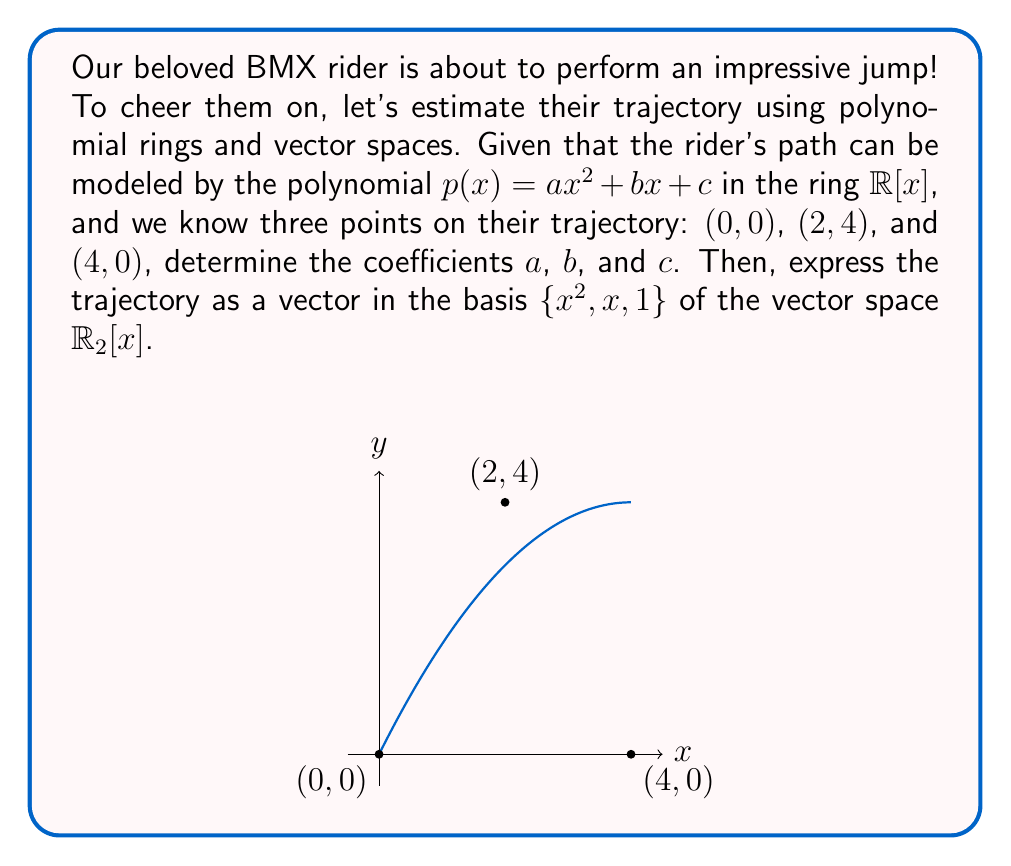Could you help me with this problem? Let's approach this step-by-step:

1) We have the polynomial $p(x) = ax^2 + bx + c$ in the ring $\mathbb{R}[x]$.

2) We know three points: $(0, 0)$, $(2, 4)$, and $(4, 0)$. Let's use these to create a system of equations:

   $p(0) = 0$: $a(0)^2 + b(0) + c = 0$, so $c = 0$
   $p(2) = 4$: $a(2)^2 + b(2) + c = 4$
   $p(4) = 0$: $a(4)^2 + b(4) + c = 0$

3) Substituting $c = 0$ into the other two equations:

   $4a + 2b = 4$
   $16a + 4b = 0$

4) Multiply the first equation by 4 and the second by -1:

   $16a + 8b = 16$
   $-16a - 4b = 0$

5) Add these equations:

   $4b = 16$
   $b = 4$

6) Substitute this back into $4a + 2b = 4$:

   $4a + 2(4) = 4$
   $4a = -4$
   $a = -1$

7) So, our polynomial is $p(x) = -x^2 + 4x$.

8) To express this as a vector in the basis $\{x^2, x, 1\}$ of $\mathbb{R}_2[x]$, we simply need to read off the coefficients:

   $p(x) = -1 \cdot x^2 + 4 \cdot x + 0 \cdot 1$

   So, the vector representation is $(-1, 4, 0)$.
Answer: $(-1, 4, 0)$ 